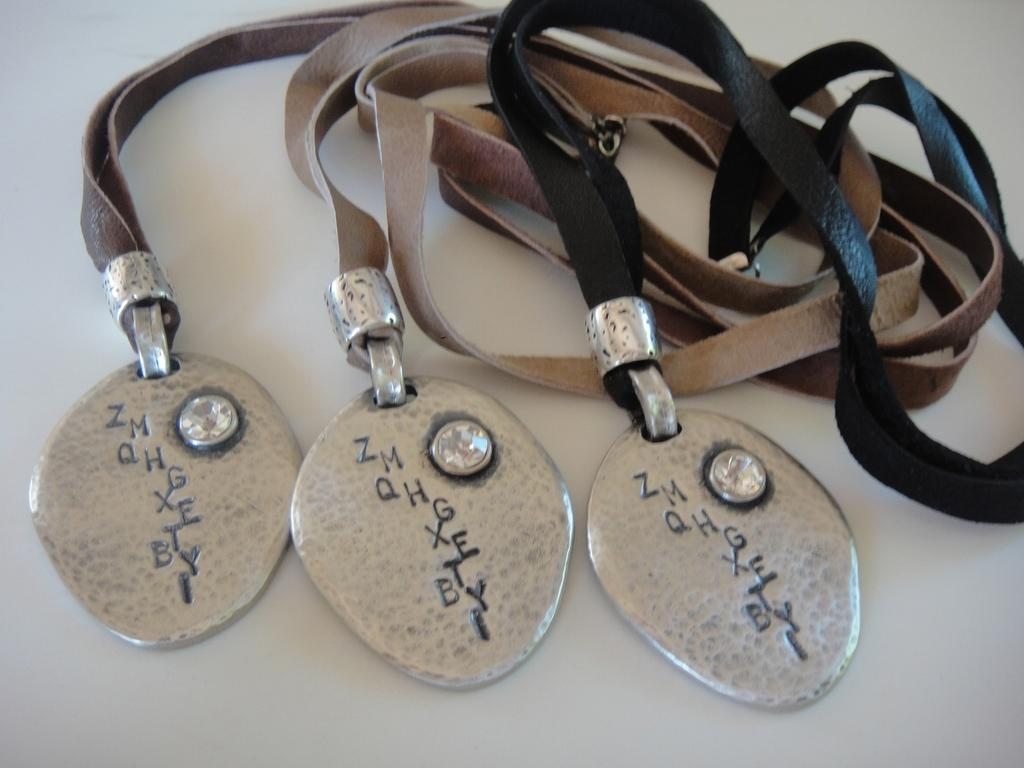What type of objects are featured in the image? There are lockets in the image. What material is used for the belts of the lockets? The lockets have leather belts. What is written or engraved on the lockets? There is text on the lockets. What shape are the news articles in the image? There are no news articles present in the image. How are the lockets being used in the image? The image does not show the lockets being used; it only shows their appearance. 